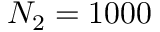<formula> <loc_0><loc_0><loc_500><loc_500>N _ { 2 } = 1 0 0 0</formula> 